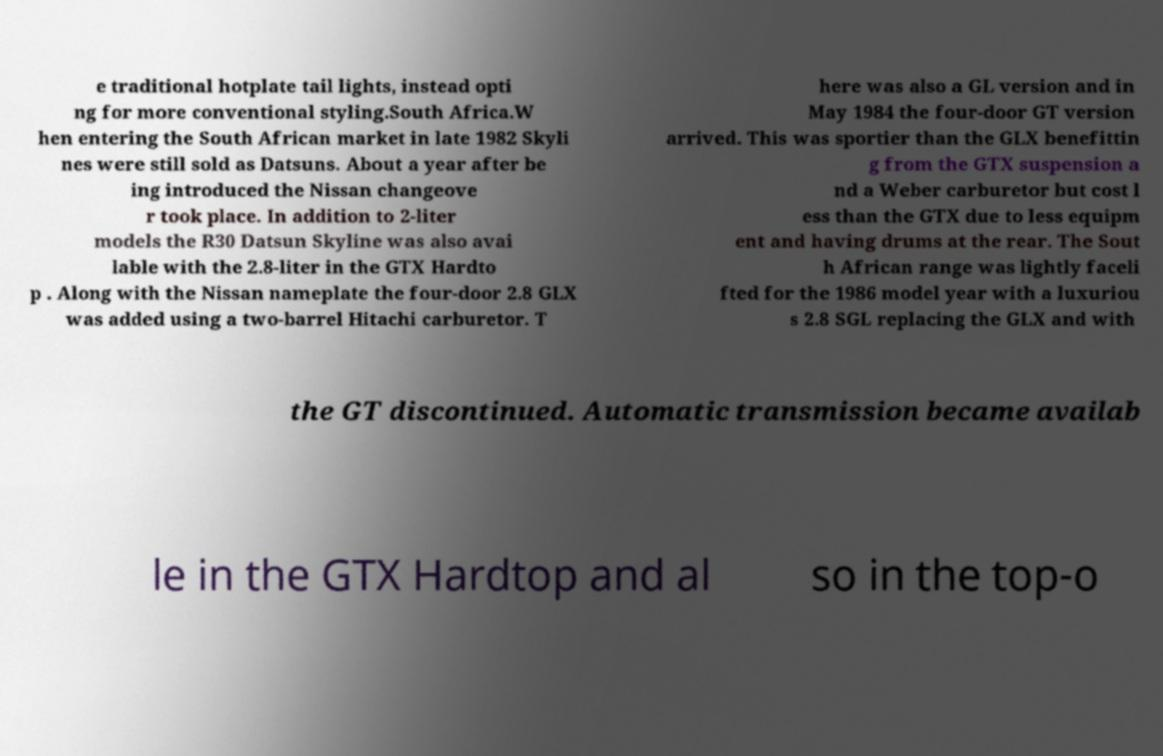Can you accurately transcribe the text from the provided image for me? e traditional hotplate tail lights, instead opti ng for more conventional styling.South Africa.W hen entering the South African market in late 1982 Skyli nes were still sold as Datsuns. About a year after be ing introduced the Nissan changeove r took place. In addition to 2-liter models the R30 Datsun Skyline was also avai lable with the 2.8-liter in the GTX Hardto p . Along with the Nissan nameplate the four-door 2.8 GLX was added using a two-barrel Hitachi carburetor. T here was also a GL version and in May 1984 the four-door GT version arrived. This was sportier than the GLX benefittin g from the GTX suspension a nd a Weber carburetor but cost l ess than the GTX due to less equipm ent and having drums at the rear. The Sout h African range was lightly faceli fted for the 1986 model year with a luxuriou s 2.8 SGL replacing the GLX and with the GT discontinued. Automatic transmission became availab le in the GTX Hardtop and al so in the top-o 